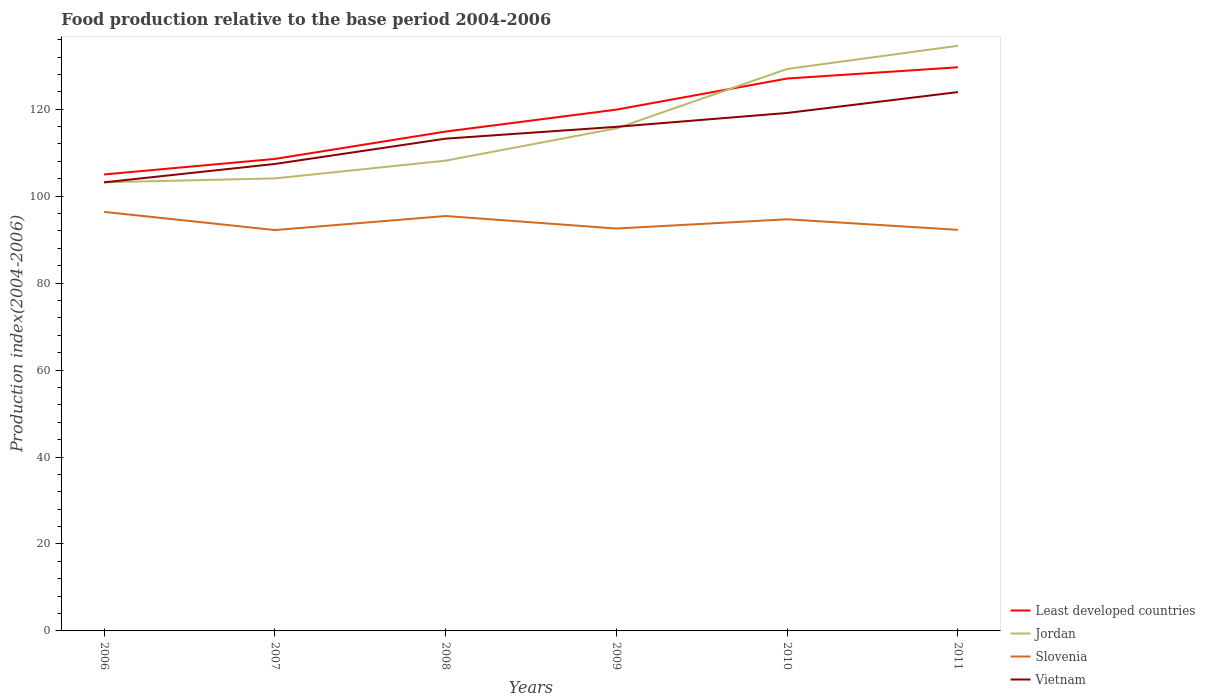How many different coloured lines are there?
Your answer should be compact. 4. Across all years, what is the maximum food production index in Slovenia?
Your response must be concise. 92.2. What is the total food production index in Least developed countries in the graph?
Give a very brief answer. -7.16. What is the difference between the highest and the second highest food production index in Vietnam?
Your answer should be very brief. 20.76. What is the difference between the highest and the lowest food production index in Slovenia?
Ensure brevity in your answer.  3. How many lines are there?
Provide a short and direct response. 4. Are the values on the major ticks of Y-axis written in scientific E-notation?
Provide a short and direct response. No. Does the graph contain any zero values?
Provide a short and direct response. No. Where does the legend appear in the graph?
Your answer should be compact. Bottom right. How many legend labels are there?
Offer a very short reply. 4. How are the legend labels stacked?
Give a very brief answer. Vertical. What is the title of the graph?
Keep it short and to the point. Food production relative to the base period 2004-2006. What is the label or title of the X-axis?
Keep it short and to the point. Years. What is the label or title of the Y-axis?
Ensure brevity in your answer.  Production index(2004-2006). What is the Production index(2004-2006) of Least developed countries in 2006?
Ensure brevity in your answer.  104.98. What is the Production index(2004-2006) in Jordan in 2006?
Offer a terse response. 103.18. What is the Production index(2004-2006) in Slovenia in 2006?
Provide a short and direct response. 96.38. What is the Production index(2004-2006) of Vietnam in 2006?
Offer a very short reply. 103.17. What is the Production index(2004-2006) of Least developed countries in 2007?
Your answer should be compact. 108.56. What is the Production index(2004-2006) in Jordan in 2007?
Offer a terse response. 104.08. What is the Production index(2004-2006) of Slovenia in 2007?
Make the answer very short. 92.2. What is the Production index(2004-2006) in Vietnam in 2007?
Make the answer very short. 107.4. What is the Production index(2004-2006) of Least developed countries in 2008?
Offer a very short reply. 114.85. What is the Production index(2004-2006) in Jordan in 2008?
Your answer should be very brief. 108.16. What is the Production index(2004-2006) of Slovenia in 2008?
Provide a short and direct response. 95.43. What is the Production index(2004-2006) in Vietnam in 2008?
Provide a succinct answer. 113.22. What is the Production index(2004-2006) in Least developed countries in 2009?
Provide a short and direct response. 119.89. What is the Production index(2004-2006) of Jordan in 2009?
Your response must be concise. 115.58. What is the Production index(2004-2006) in Slovenia in 2009?
Ensure brevity in your answer.  92.55. What is the Production index(2004-2006) in Vietnam in 2009?
Your response must be concise. 115.94. What is the Production index(2004-2006) in Least developed countries in 2010?
Your answer should be very brief. 127.05. What is the Production index(2004-2006) of Jordan in 2010?
Ensure brevity in your answer.  129.25. What is the Production index(2004-2006) in Slovenia in 2010?
Give a very brief answer. 94.68. What is the Production index(2004-2006) of Vietnam in 2010?
Offer a very short reply. 119.13. What is the Production index(2004-2006) in Least developed countries in 2011?
Provide a succinct answer. 129.63. What is the Production index(2004-2006) in Jordan in 2011?
Offer a terse response. 134.58. What is the Production index(2004-2006) in Slovenia in 2011?
Give a very brief answer. 92.25. What is the Production index(2004-2006) in Vietnam in 2011?
Provide a short and direct response. 123.93. Across all years, what is the maximum Production index(2004-2006) in Least developed countries?
Your answer should be compact. 129.63. Across all years, what is the maximum Production index(2004-2006) of Jordan?
Your answer should be very brief. 134.58. Across all years, what is the maximum Production index(2004-2006) of Slovenia?
Offer a very short reply. 96.38. Across all years, what is the maximum Production index(2004-2006) in Vietnam?
Offer a terse response. 123.93. Across all years, what is the minimum Production index(2004-2006) of Least developed countries?
Give a very brief answer. 104.98. Across all years, what is the minimum Production index(2004-2006) of Jordan?
Offer a very short reply. 103.18. Across all years, what is the minimum Production index(2004-2006) in Slovenia?
Provide a short and direct response. 92.2. Across all years, what is the minimum Production index(2004-2006) in Vietnam?
Provide a succinct answer. 103.17. What is the total Production index(2004-2006) of Least developed countries in the graph?
Provide a succinct answer. 704.97. What is the total Production index(2004-2006) of Jordan in the graph?
Ensure brevity in your answer.  694.83. What is the total Production index(2004-2006) in Slovenia in the graph?
Your response must be concise. 563.49. What is the total Production index(2004-2006) in Vietnam in the graph?
Your response must be concise. 682.79. What is the difference between the Production index(2004-2006) in Least developed countries in 2006 and that in 2007?
Ensure brevity in your answer.  -3.58. What is the difference between the Production index(2004-2006) of Jordan in 2006 and that in 2007?
Provide a succinct answer. -0.9. What is the difference between the Production index(2004-2006) in Slovenia in 2006 and that in 2007?
Your answer should be very brief. 4.18. What is the difference between the Production index(2004-2006) of Vietnam in 2006 and that in 2007?
Give a very brief answer. -4.23. What is the difference between the Production index(2004-2006) in Least developed countries in 2006 and that in 2008?
Your response must be concise. -9.87. What is the difference between the Production index(2004-2006) in Jordan in 2006 and that in 2008?
Provide a succinct answer. -4.98. What is the difference between the Production index(2004-2006) in Vietnam in 2006 and that in 2008?
Keep it short and to the point. -10.05. What is the difference between the Production index(2004-2006) of Least developed countries in 2006 and that in 2009?
Your answer should be compact. -14.91. What is the difference between the Production index(2004-2006) in Slovenia in 2006 and that in 2009?
Offer a very short reply. 3.83. What is the difference between the Production index(2004-2006) in Vietnam in 2006 and that in 2009?
Offer a terse response. -12.77. What is the difference between the Production index(2004-2006) of Least developed countries in 2006 and that in 2010?
Your response must be concise. -22.07. What is the difference between the Production index(2004-2006) in Jordan in 2006 and that in 2010?
Your answer should be compact. -26.07. What is the difference between the Production index(2004-2006) in Vietnam in 2006 and that in 2010?
Keep it short and to the point. -15.96. What is the difference between the Production index(2004-2006) in Least developed countries in 2006 and that in 2011?
Offer a terse response. -24.65. What is the difference between the Production index(2004-2006) of Jordan in 2006 and that in 2011?
Your answer should be compact. -31.4. What is the difference between the Production index(2004-2006) in Slovenia in 2006 and that in 2011?
Ensure brevity in your answer.  4.13. What is the difference between the Production index(2004-2006) of Vietnam in 2006 and that in 2011?
Provide a succinct answer. -20.76. What is the difference between the Production index(2004-2006) of Least developed countries in 2007 and that in 2008?
Give a very brief answer. -6.29. What is the difference between the Production index(2004-2006) of Jordan in 2007 and that in 2008?
Provide a short and direct response. -4.08. What is the difference between the Production index(2004-2006) in Slovenia in 2007 and that in 2008?
Your response must be concise. -3.23. What is the difference between the Production index(2004-2006) of Vietnam in 2007 and that in 2008?
Provide a short and direct response. -5.82. What is the difference between the Production index(2004-2006) in Least developed countries in 2007 and that in 2009?
Your answer should be compact. -11.33. What is the difference between the Production index(2004-2006) in Slovenia in 2007 and that in 2009?
Provide a short and direct response. -0.35. What is the difference between the Production index(2004-2006) of Vietnam in 2007 and that in 2009?
Provide a short and direct response. -8.54. What is the difference between the Production index(2004-2006) of Least developed countries in 2007 and that in 2010?
Offer a terse response. -18.49. What is the difference between the Production index(2004-2006) in Jordan in 2007 and that in 2010?
Keep it short and to the point. -25.17. What is the difference between the Production index(2004-2006) in Slovenia in 2007 and that in 2010?
Make the answer very short. -2.48. What is the difference between the Production index(2004-2006) of Vietnam in 2007 and that in 2010?
Provide a short and direct response. -11.73. What is the difference between the Production index(2004-2006) in Least developed countries in 2007 and that in 2011?
Ensure brevity in your answer.  -21.07. What is the difference between the Production index(2004-2006) in Jordan in 2007 and that in 2011?
Your answer should be compact. -30.5. What is the difference between the Production index(2004-2006) of Slovenia in 2007 and that in 2011?
Ensure brevity in your answer.  -0.05. What is the difference between the Production index(2004-2006) of Vietnam in 2007 and that in 2011?
Offer a terse response. -16.53. What is the difference between the Production index(2004-2006) of Least developed countries in 2008 and that in 2009?
Offer a terse response. -5.04. What is the difference between the Production index(2004-2006) of Jordan in 2008 and that in 2009?
Make the answer very short. -7.42. What is the difference between the Production index(2004-2006) of Slovenia in 2008 and that in 2009?
Give a very brief answer. 2.88. What is the difference between the Production index(2004-2006) of Vietnam in 2008 and that in 2009?
Ensure brevity in your answer.  -2.72. What is the difference between the Production index(2004-2006) of Least developed countries in 2008 and that in 2010?
Ensure brevity in your answer.  -12.2. What is the difference between the Production index(2004-2006) of Jordan in 2008 and that in 2010?
Give a very brief answer. -21.09. What is the difference between the Production index(2004-2006) in Slovenia in 2008 and that in 2010?
Keep it short and to the point. 0.75. What is the difference between the Production index(2004-2006) of Vietnam in 2008 and that in 2010?
Your answer should be very brief. -5.91. What is the difference between the Production index(2004-2006) of Least developed countries in 2008 and that in 2011?
Provide a short and direct response. -14.78. What is the difference between the Production index(2004-2006) of Jordan in 2008 and that in 2011?
Your response must be concise. -26.42. What is the difference between the Production index(2004-2006) in Slovenia in 2008 and that in 2011?
Offer a terse response. 3.18. What is the difference between the Production index(2004-2006) of Vietnam in 2008 and that in 2011?
Provide a short and direct response. -10.71. What is the difference between the Production index(2004-2006) in Least developed countries in 2009 and that in 2010?
Make the answer very short. -7.16. What is the difference between the Production index(2004-2006) in Jordan in 2009 and that in 2010?
Give a very brief answer. -13.67. What is the difference between the Production index(2004-2006) of Slovenia in 2009 and that in 2010?
Make the answer very short. -2.13. What is the difference between the Production index(2004-2006) in Vietnam in 2009 and that in 2010?
Your response must be concise. -3.19. What is the difference between the Production index(2004-2006) in Least developed countries in 2009 and that in 2011?
Your answer should be very brief. -9.74. What is the difference between the Production index(2004-2006) in Jordan in 2009 and that in 2011?
Ensure brevity in your answer.  -19. What is the difference between the Production index(2004-2006) in Slovenia in 2009 and that in 2011?
Provide a short and direct response. 0.3. What is the difference between the Production index(2004-2006) of Vietnam in 2009 and that in 2011?
Your answer should be very brief. -7.99. What is the difference between the Production index(2004-2006) in Least developed countries in 2010 and that in 2011?
Provide a succinct answer. -2.58. What is the difference between the Production index(2004-2006) of Jordan in 2010 and that in 2011?
Make the answer very short. -5.33. What is the difference between the Production index(2004-2006) in Slovenia in 2010 and that in 2011?
Your answer should be compact. 2.43. What is the difference between the Production index(2004-2006) in Vietnam in 2010 and that in 2011?
Offer a terse response. -4.8. What is the difference between the Production index(2004-2006) in Least developed countries in 2006 and the Production index(2004-2006) in Jordan in 2007?
Ensure brevity in your answer.  0.9. What is the difference between the Production index(2004-2006) in Least developed countries in 2006 and the Production index(2004-2006) in Slovenia in 2007?
Make the answer very short. 12.78. What is the difference between the Production index(2004-2006) in Least developed countries in 2006 and the Production index(2004-2006) in Vietnam in 2007?
Make the answer very short. -2.42. What is the difference between the Production index(2004-2006) in Jordan in 2006 and the Production index(2004-2006) in Slovenia in 2007?
Your answer should be compact. 10.98. What is the difference between the Production index(2004-2006) of Jordan in 2006 and the Production index(2004-2006) of Vietnam in 2007?
Your response must be concise. -4.22. What is the difference between the Production index(2004-2006) of Slovenia in 2006 and the Production index(2004-2006) of Vietnam in 2007?
Your answer should be compact. -11.02. What is the difference between the Production index(2004-2006) of Least developed countries in 2006 and the Production index(2004-2006) of Jordan in 2008?
Offer a very short reply. -3.18. What is the difference between the Production index(2004-2006) in Least developed countries in 2006 and the Production index(2004-2006) in Slovenia in 2008?
Ensure brevity in your answer.  9.55. What is the difference between the Production index(2004-2006) of Least developed countries in 2006 and the Production index(2004-2006) of Vietnam in 2008?
Ensure brevity in your answer.  -8.24. What is the difference between the Production index(2004-2006) of Jordan in 2006 and the Production index(2004-2006) of Slovenia in 2008?
Provide a short and direct response. 7.75. What is the difference between the Production index(2004-2006) of Jordan in 2006 and the Production index(2004-2006) of Vietnam in 2008?
Provide a short and direct response. -10.04. What is the difference between the Production index(2004-2006) in Slovenia in 2006 and the Production index(2004-2006) in Vietnam in 2008?
Make the answer very short. -16.84. What is the difference between the Production index(2004-2006) in Least developed countries in 2006 and the Production index(2004-2006) in Jordan in 2009?
Your answer should be compact. -10.6. What is the difference between the Production index(2004-2006) of Least developed countries in 2006 and the Production index(2004-2006) of Slovenia in 2009?
Provide a short and direct response. 12.43. What is the difference between the Production index(2004-2006) in Least developed countries in 2006 and the Production index(2004-2006) in Vietnam in 2009?
Provide a succinct answer. -10.96. What is the difference between the Production index(2004-2006) of Jordan in 2006 and the Production index(2004-2006) of Slovenia in 2009?
Provide a short and direct response. 10.63. What is the difference between the Production index(2004-2006) in Jordan in 2006 and the Production index(2004-2006) in Vietnam in 2009?
Give a very brief answer. -12.76. What is the difference between the Production index(2004-2006) of Slovenia in 2006 and the Production index(2004-2006) of Vietnam in 2009?
Offer a terse response. -19.56. What is the difference between the Production index(2004-2006) of Least developed countries in 2006 and the Production index(2004-2006) of Jordan in 2010?
Ensure brevity in your answer.  -24.27. What is the difference between the Production index(2004-2006) in Least developed countries in 2006 and the Production index(2004-2006) in Slovenia in 2010?
Ensure brevity in your answer.  10.3. What is the difference between the Production index(2004-2006) in Least developed countries in 2006 and the Production index(2004-2006) in Vietnam in 2010?
Offer a very short reply. -14.15. What is the difference between the Production index(2004-2006) in Jordan in 2006 and the Production index(2004-2006) in Slovenia in 2010?
Give a very brief answer. 8.5. What is the difference between the Production index(2004-2006) in Jordan in 2006 and the Production index(2004-2006) in Vietnam in 2010?
Provide a succinct answer. -15.95. What is the difference between the Production index(2004-2006) in Slovenia in 2006 and the Production index(2004-2006) in Vietnam in 2010?
Ensure brevity in your answer.  -22.75. What is the difference between the Production index(2004-2006) of Least developed countries in 2006 and the Production index(2004-2006) of Jordan in 2011?
Give a very brief answer. -29.6. What is the difference between the Production index(2004-2006) in Least developed countries in 2006 and the Production index(2004-2006) in Slovenia in 2011?
Your answer should be compact. 12.73. What is the difference between the Production index(2004-2006) of Least developed countries in 2006 and the Production index(2004-2006) of Vietnam in 2011?
Your response must be concise. -18.95. What is the difference between the Production index(2004-2006) in Jordan in 2006 and the Production index(2004-2006) in Slovenia in 2011?
Your response must be concise. 10.93. What is the difference between the Production index(2004-2006) of Jordan in 2006 and the Production index(2004-2006) of Vietnam in 2011?
Make the answer very short. -20.75. What is the difference between the Production index(2004-2006) in Slovenia in 2006 and the Production index(2004-2006) in Vietnam in 2011?
Provide a succinct answer. -27.55. What is the difference between the Production index(2004-2006) of Least developed countries in 2007 and the Production index(2004-2006) of Jordan in 2008?
Offer a very short reply. 0.4. What is the difference between the Production index(2004-2006) of Least developed countries in 2007 and the Production index(2004-2006) of Slovenia in 2008?
Your answer should be very brief. 13.13. What is the difference between the Production index(2004-2006) of Least developed countries in 2007 and the Production index(2004-2006) of Vietnam in 2008?
Give a very brief answer. -4.66. What is the difference between the Production index(2004-2006) of Jordan in 2007 and the Production index(2004-2006) of Slovenia in 2008?
Your response must be concise. 8.65. What is the difference between the Production index(2004-2006) in Jordan in 2007 and the Production index(2004-2006) in Vietnam in 2008?
Your response must be concise. -9.14. What is the difference between the Production index(2004-2006) in Slovenia in 2007 and the Production index(2004-2006) in Vietnam in 2008?
Your answer should be very brief. -21.02. What is the difference between the Production index(2004-2006) in Least developed countries in 2007 and the Production index(2004-2006) in Jordan in 2009?
Keep it short and to the point. -7.02. What is the difference between the Production index(2004-2006) in Least developed countries in 2007 and the Production index(2004-2006) in Slovenia in 2009?
Your response must be concise. 16.01. What is the difference between the Production index(2004-2006) of Least developed countries in 2007 and the Production index(2004-2006) of Vietnam in 2009?
Provide a short and direct response. -7.38. What is the difference between the Production index(2004-2006) in Jordan in 2007 and the Production index(2004-2006) in Slovenia in 2009?
Your answer should be very brief. 11.53. What is the difference between the Production index(2004-2006) of Jordan in 2007 and the Production index(2004-2006) of Vietnam in 2009?
Provide a short and direct response. -11.86. What is the difference between the Production index(2004-2006) in Slovenia in 2007 and the Production index(2004-2006) in Vietnam in 2009?
Give a very brief answer. -23.74. What is the difference between the Production index(2004-2006) in Least developed countries in 2007 and the Production index(2004-2006) in Jordan in 2010?
Give a very brief answer. -20.69. What is the difference between the Production index(2004-2006) in Least developed countries in 2007 and the Production index(2004-2006) in Slovenia in 2010?
Make the answer very short. 13.88. What is the difference between the Production index(2004-2006) in Least developed countries in 2007 and the Production index(2004-2006) in Vietnam in 2010?
Give a very brief answer. -10.57. What is the difference between the Production index(2004-2006) in Jordan in 2007 and the Production index(2004-2006) in Slovenia in 2010?
Give a very brief answer. 9.4. What is the difference between the Production index(2004-2006) in Jordan in 2007 and the Production index(2004-2006) in Vietnam in 2010?
Your answer should be very brief. -15.05. What is the difference between the Production index(2004-2006) of Slovenia in 2007 and the Production index(2004-2006) of Vietnam in 2010?
Your answer should be very brief. -26.93. What is the difference between the Production index(2004-2006) of Least developed countries in 2007 and the Production index(2004-2006) of Jordan in 2011?
Offer a terse response. -26.02. What is the difference between the Production index(2004-2006) of Least developed countries in 2007 and the Production index(2004-2006) of Slovenia in 2011?
Offer a terse response. 16.31. What is the difference between the Production index(2004-2006) of Least developed countries in 2007 and the Production index(2004-2006) of Vietnam in 2011?
Keep it short and to the point. -15.37. What is the difference between the Production index(2004-2006) in Jordan in 2007 and the Production index(2004-2006) in Slovenia in 2011?
Provide a succinct answer. 11.83. What is the difference between the Production index(2004-2006) in Jordan in 2007 and the Production index(2004-2006) in Vietnam in 2011?
Your answer should be compact. -19.85. What is the difference between the Production index(2004-2006) of Slovenia in 2007 and the Production index(2004-2006) of Vietnam in 2011?
Provide a succinct answer. -31.73. What is the difference between the Production index(2004-2006) of Least developed countries in 2008 and the Production index(2004-2006) of Jordan in 2009?
Your answer should be compact. -0.73. What is the difference between the Production index(2004-2006) of Least developed countries in 2008 and the Production index(2004-2006) of Slovenia in 2009?
Keep it short and to the point. 22.3. What is the difference between the Production index(2004-2006) of Least developed countries in 2008 and the Production index(2004-2006) of Vietnam in 2009?
Provide a short and direct response. -1.09. What is the difference between the Production index(2004-2006) of Jordan in 2008 and the Production index(2004-2006) of Slovenia in 2009?
Ensure brevity in your answer.  15.61. What is the difference between the Production index(2004-2006) in Jordan in 2008 and the Production index(2004-2006) in Vietnam in 2009?
Your answer should be very brief. -7.78. What is the difference between the Production index(2004-2006) in Slovenia in 2008 and the Production index(2004-2006) in Vietnam in 2009?
Your response must be concise. -20.51. What is the difference between the Production index(2004-2006) in Least developed countries in 2008 and the Production index(2004-2006) in Jordan in 2010?
Offer a very short reply. -14.4. What is the difference between the Production index(2004-2006) of Least developed countries in 2008 and the Production index(2004-2006) of Slovenia in 2010?
Your answer should be very brief. 20.17. What is the difference between the Production index(2004-2006) of Least developed countries in 2008 and the Production index(2004-2006) of Vietnam in 2010?
Provide a short and direct response. -4.28. What is the difference between the Production index(2004-2006) of Jordan in 2008 and the Production index(2004-2006) of Slovenia in 2010?
Give a very brief answer. 13.48. What is the difference between the Production index(2004-2006) of Jordan in 2008 and the Production index(2004-2006) of Vietnam in 2010?
Provide a succinct answer. -10.97. What is the difference between the Production index(2004-2006) in Slovenia in 2008 and the Production index(2004-2006) in Vietnam in 2010?
Make the answer very short. -23.7. What is the difference between the Production index(2004-2006) of Least developed countries in 2008 and the Production index(2004-2006) of Jordan in 2011?
Your answer should be very brief. -19.73. What is the difference between the Production index(2004-2006) in Least developed countries in 2008 and the Production index(2004-2006) in Slovenia in 2011?
Your response must be concise. 22.6. What is the difference between the Production index(2004-2006) of Least developed countries in 2008 and the Production index(2004-2006) of Vietnam in 2011?
Offer a terse response. -9.08. What is the difference between the Production index(2004-2006) in Jordan in 2008 and the Production index(2004-2006) in Slovenia in 2011?
Offer a very short reply. 15.91. What is the difference between the Production index(2004-2006) of Jordan in 2008 and the Production index(2004-2006) of Vietnam in 2011?
Give a very brief answer. -15.77. What is the difference between the Production index(2004-2006) of Slovenia in 2008 and the Production index(2004-2006) of Vietnam in 2011?
Make the answer very short. -28.5. What is the difference between the Production index(2004-2006) in Least developed countries in 2009 and the Production index(2004-2006) in Jordan in 2010?
Give a very brief answer. -9.36. What is the difference between the Production index(2004-2006) of Least developed countries in 2009 and the Production index(2004-2006) of Slovenia in 2010?
Your answer should be very brief. 25.21. What is the difference between the Production index(2004-2006) of Least developed countries in 2009 and the Production index(2004-2006) of Vietnam in 2010?
Offer a terse response. 0.76. What is the difference between the Production index(2004-2006) in Jordan in 2009 and the Production index(2004-2006) in Slovenia in 2010?
Provide a succinct answer. 20.9. What is the difference between the Production index(2004-2006) of Jordan in 2009 and the Production index(2004-2006) of Vietnam in 2010?
Your response must be concise. -3.55. What is the difference between the Production index(2004-2006) of Slovenia in 2009 and the Production index(2004-2006) of Vietnam in 2010?
Offer a terse response. -26.58. What is the difference between the Production index(2004-2006) of Least developed countries in 2009 and the Production index(2004-2006) of Jordan in 2011?
Keep it short and to the point. -14.69. What is the difference between the Production index(2004-2006) in Least developed countries in 2009 and the Production index(2004-2006) in Slovenia in 2011?
Offer a very short reply. 27.64. What is the difference between the Production index(2004-2006) in Least developed countries in 2009 and the Production index(2004-2006) in Vietnam in 2011?
Keep it short and to the point. -4.04. What is the difference between the Production index(2004-2006) of Jordan in 2009 and the Production index(2004-2006) of Slovenia in 2011?
Your answer should be very brief. 23.33. What is the difference between the Production index(2004-2006) of Jordan in 2009 and the Production index(2004-2006) of Vietnam in 2011?
Keep it short and to the point. -8.35. What is the difference between the Production index(2004-2006) of Slovenia in 2009 and the Production index(2004-2006) of Vietnam in 2011?
Your answer should be compact. -31.38. What is the difference between the Production index(2004-2006) in Least developed countries in 2010 and the Production index(2004-2006) in Jordan in 2011?
Your answer should be very brief. -7.53. What is the difference between the Production index(2004-2006) in Least developed countries in 2010 and the Production index(2004-2006) in Slovenia in 2011?
Your answer should be very brief. 34.8. What is the difference between the Production index(2004-2006) in Least developed countries in 2010 and the Production index(2004-2006) in Vietnam in 2011?
Your answer should be compact. 3.12. What is the difference between the Production index(2004-2006) of Jordan in 2010 and the Production index(2004-2006) of Vietnam in 2011?
Your response must be concise. 5.32. What is the difference between the Production index(2004-2006) of Slovenia in 2010 and the Production index(2004-2006) of Vietnam in 2011?
Your answer should be compact. -29.25. What is the average Production index(2004-2006) in Least developed countries per year?
Provide a succinct answer. 117.5. What is the average Production index(2004-2006) in Jordan per year?
Your answer should be very brief. 115.81. What is the average Production index(2004-2006) in Slovenia per year?
Your answer should be very brief. 93.92. What is the average Production index(2004-2006) in Vietnam per year?
Your response must be concise. 113.8. In the year 2006, what is the difference between the Production index(2004-2006) in Least developed countries and Production index(2004-2006) in Jordan?
Offer a terse response. 1.8. In the year 2006, what is the difference between the Production index(2004-2006) of Least developed countries and Production index(2004-2006) of Slovenia?
Keep it short and to the point. 8.6. In the year 2006, what is the difference between the Production index(2004-2006) of Least developed countries and Production index(2004-2006) of Vietnam?
Provide a short and direct response. 1.81. In the year 2006, what is the difference between the Production index(2004-2006) in Jordan and Production index(2004-2006) in Slovenia?
Your answer should be compact. 6.8. In the year 2006, what is the difference between the Production index(2004-2006) in Slovenia and Production index(2004-2006) in Vietnam?
Provide a succinct answer. -6.79. In the year 2007, what is the difference between the Production index(2004-2006) in Least developed countries and Production index(2004-2006) in Jordan?
Offer a terse response. 4.48. In the year 2007, what is the difference between the Production index(2004-2006) of Least developed countries and Production index(2004-2006) of Slovenia?
Offer a very short reply. 16.36. In the year 2007, what is the difference between the Production index(2004-2006) of Least developed countries and Production index(2004-2006) of Vietnam?
Provide a succinct answer. 1.16. In the year 2007, what is the difference between the Production index(2004-2006) in Jordan and Production index(2004-2006) in Slovenia?
Your response must be concise. 11.88. In the year 2007, what is the difference between the Production index(2004-2006) in Jordan and Production index(2004-2006) in Vietnam?
Offer a very short reply. -3.32. In the year 2007, what is the difference between the Production index(2004-2006) of Slovenia and Production index(2004-2006) of Vietnam?
Your answer should be very brief. -15.2. In the year 2008, what is the difference between the Production index(2004-2006) in Least developed countries and Production index(2004-2006) in Jordan?
Your answer should be very brief. 6.69. In the year 2008, what is the difference between the Production index(2004-2006) in Least developed countries and Production index(2004-2006) in Slovenia?
Your answer should be compact. 19.42. In the year 2008, what is the difference between the Production index(2004-2006) of Least developed countries and Production index(2004-2006) of Vietnam?
Make the answer very short. 1.63. In the year 2008, what is the difference between the Production index(2004-2006) in Jordan and Production index(2004-2006) in Slovenia?
Your response must be concise. 12.73. In the year 2008, what is the difference between the Production index(2004-2006) of Jordan and Production index(2004-2006) of Vietnam?
Give a very brief answer. -5.06. In the year 2008, what is the difference between the Production index(2004-2006) in Slovenia and Production index(2004-2006) in Vietnam?
Provide a succinct answer. -17.79. In the year 2009, what is the difference between the Production index(2004-2006) of Least developed countries and Production index(2004-2006) of Jordan?
Provide a short and direct response. 4.31. In the year 2009, what is the difference between the Production index(2004-2006) in Least developed countries and Production index(2004-2006) in Slovenia?
Provide a succinct answer. 27.34. In the year 2009, what is the difference between the Production index(2004-2006) of Least developed countries and Production index(2004-2006) of Vietnam?
Offer a terse response. 3.95. In the year 2009, what is the difference between the Production index(2004-2006) in Jordan and Production index(2004-2006) in Slovenia?
Provide a short and direct response. 23.03. In the year 2009, what is the difference between the Production index(2004-2006) of Jordan and Production index(2004-2006) of Vietnam?
Provide a short and direct response. -0.36. In the year 2009, what is the difference between the Production index(2004-2006) in Slovenia and Production index(2004-2006) in Vietnam?
Your answer should be very brief. -23.39. In the year 2010, what is the difference between the Production index(2004-2006) in Least developed countries and Production index(2004-2006) in Jordan?
Provide a succinct answer. -2.2. In the year 2010, what is the difference between the Production index(2004-2006) of Least developed countries and Production index(2004-2006) of Slovenia?
Keep it short and to the point. 32.37. In the year 2010, what is the difference between the Production index(2004-2006) of Least developed countries and Production index(2004-2006) of Vietnam?
Provide a short and direct response. 7.92. In the year 2010, what is the difference between the Production index(2004-2006) of Jordan and Production index(2004-2006) of Slovenia?
Give a very brief answer. 34.57. In the year 2010, what is the difference between the Production index(2004-2006) in Jordan and Production index(2004-2006) in Vietnam?
Ensure brevity in your answer.  10.12. In the year 2010, what is the difference between the Production index(2004-2006) of Slovenia and Production index(2004-2006) of Vietnam?
Offer a terse response. -24.45. In the year 2011, what is the difference between the Production index(2004-2006) of Least developed countries and Production index(2004-2006) of Jordan?
Your answer should be compact. -4.95. In the year 2011, what is the difference between the Production index(2004-2006) of Least developed countries and Production index(2004-2006) of Slovenia?
Ensure brevity in your answer.  37.38. In the year 2011, what is the difference between the Production index(2004-2006) in Least developed countries and Production index(2004-2006) in Vietnam?
Your answer should be compact. 5.7. In the year 2011, what is the difference between the Production index(2004-2006) in Jordan and Production index(2004-2006) in Slovenia?
Your answer should be very brief. 42.33. In the year 2011, what is the difference between the Production index(2004-2006) of Jordan and Production index(2004-2006) of Vietnam?
Provide a short and direct response. 10.65. In the year 2011, what is the difference between the Production index(2004-2006) in Slovenia and Production index(2004-2006) in Vietnam?
Your answer should be very brief. -31.68. What is the ratio of the Production index(2004-2006) in Jordan in 2006 to that in 2007?
Keep it short and to the point. 0.99. What is the ratio of the Production index(2004-2006) in Slovenia in 2006 to that in 2007?
Your response must be concise. 1.05. What is the ratio of the Production index(2004-2006) in Vietnam in 2006 to that in 2007?
Your answer should be very brief. 0.96. What is the ratio of the Production index(2004-2006) of Least developed countries in 2006 to that in 2008?
Keep it short and to the point. 0.91. What is the ratio of the Production index(2004-2006) of Jordan in 2006 to that in 2008?
Your answer should be very brief. 0.95. What is the ratio of the Production index(2004-2006) in Slovenia in 2006 to that in 2008?
Offer a terse response. 1.01. What is the ratio of the Production index(2004-2006) in Vietnam in 2006 to that in 2008?
Your answer should be compact. 0.91. What is the ratio of the Production index(2004-2006) of Least developed countries in 2006 to that in 2009?
Keep it short and to the point. 0.88. What is the ratio of the Production index(2004-2006) of Jordan in 2006 to that in 2009?
Your answer should be very brief. 0.89. What is the ratio of the Production index(2004-2006) of Slovenia in 2006 to that in 2009?
Ensure brevity in your answer.  1.04. What is the ratio of the Production index(2004-2006) of Vietnam in 2006 to that in 2009?
Your answer should be compact. 0.89. What is the ratio of the Production index(2004-2006) of Least developed countries in 2006 to that in 2010?
Provide a succinct answer. 0.83. What is the ratio of the Production index(2004-2006) in Jordan in 2006 to that in 2010?
Ensure brevity in your answer.  0.8. What is the ratio of the Production index(2004-2006) in Vietnam in 2006 to that in 2010?
Keep it short and to the point. 0.87. What is the ratio of the Production index(2004-2006) of Least developed countries in 2006 to that in 2011?
Ensure brevity in your answer.  0.81. What is the ratio of the Production index(2004-2006) in Jordan in 2006 to that in 2011?
Your answer should be very brief. 0.77. What is the ratio of the Production index(2004-2006) of Slovenia in 2006 to that in 2011?
Provide a short and direct response. 1.04. What is the ratio of the Production index(2004-2006) in Vietnam in 2006 to that in 2011?
Give a very brief answer. 0.83. What is the ratio of the Production index(2004-2006) in Least developed countries in 2007 to that in 2008?
Offer a terse response. 0.95. What is the ratio of the Production index(2004-2006) in Jordan in 2007 to that in 2008?
Make the answer very short. 0.96. What is the ratio of the Production index(2004-2006) of Slovenia in 2007 to that in 2008?
Provide a succinct answer. 0.97. What is the ratio of the Production index(2004-2006) in Vietnam in 2007 to that in 2008?
Your answer should be compact. 0.95. What is the ratio of the Production index(2004-2006) of Least developed countries in 2007 to that in 2009?
Your answer should be very brief. 0.91. What is the ratio of the Production index(2004-2006) of Jordan in 2007 to that in 2009?
Your answer should be compact. 0.9. What is the ratio of the Production index(2004-2006) of Vietnam in 2007 to that in 2009?
Give a very brief answer. 0.93. What is the ratio of the Production index(2004-2006) of Least developed countries in 2007 to that in 2010?
Provide a short and direct response. 0.85. What is the ratio of the Production index(2004-2006) of Jordan in 2007 to that in 2010?
Your answer should be compact. 0.81. What is the ratio of the Production index(2004-2006) in Slovenia in 2007 to that in 2010?
Offer a terse response. 0.97. What is the ratio of the Production index(2004-2006) of Vietnam in 2007 to that in 2010?
Provide a succinct answer. 0.9. What is the ratio of the Production index(2004-2006) in Least developed countries in 2007 to that in 2011?
Keep it short and to the point. 0.84. What is the ratio of the Production index(2004-2006) of Jordan in 2007 to that in 2011?
Give a very brief answer. 0.77. What is the ratio of the Production index(2004-2006) in Vietnam in 2007 to that in 2011?
Your response must be concise. 0.87. What is the ratio of the Production index(2004-2006) of Least developed countries in 2008 to that in 2009?
Ensure brevity in your answer.  0.96. What is the ratio of the Production index(2004-2006) of Jordan in 2008 to that in 2009?
Make the answer very short. 0.94. What is the ratio of the Production index(2004-2006) of Slovenia in 2008 to that in 2009?
Offer a very short reply. 1.03. What is the ratio of the Production index(2004-2006) of Vietnam in 2008 to that in 2009?
Keep it short and to the point. 0.98. What is the ratio of the Production index(2004-2006) of Least developed countries in 2008 to that in 2010?
Offer a terse response. 0.9. What is the ratio of the Production index(2004-2006) in Jordan in 2008 to that in 2010?
Provide a short and direct response. 0.84. What is the ratio of the Production index(2004-2006) of Slovenia in 2008 to that in 2010?
Keep it short and to the point. 1.01. What is the ratio of the Production index(2004-2006) of Vietnam in 2008 to that in 2010?
Your response must be concise. 0.95. What is the ratio of the Production index(2004-2006) of Least developed countries in 2008 to that in 2011?
Your answer should be very brief. 0.89. What is the ratio of the Production index(2004-2006) of Jordan in 2008 to that in 2011?
Your response must be concise. 0.8. What is the ratio of the Production index(2004-2006) of Slovenia in 2008 to that in 2011?
Your answer should be compact. 1.03. What is the ratio of the Production index(2004-2006) of Vietnam in 2008 to that in 2011?
Offer a very short reply. 0.91. What is the ratio of the Production index(2004-2006) of Least developed countries in 2009 to that in 2010?
Provide a succinct answer. 0.94. What is the ratio of the Production index(2004-2006) of Jordan in 2009 to that in 2010?
Offer a very short reply. 0.89. What is the ratio of the Production index(2004-2006) of Slovenia in 2009 to that in 2010?
Keep it short and to the point. 0.98. What is the ratio of the Production index(2004-2006) of Vietnam in 2009 to that in 2010?
Keep it short and to the point. 0.97. What is the ratio of the Production index(2004-2006) of Least developed countries in 2009 to that in 2011?
Make the answer very short. 0.92. What is the ratio of the Production index(2004-2006) of Jordan in 2009 to that in 2011?
Your response must be concise. 0.86. What is the ratio of the Production index(2004-2006) in Slovenia in 2009 to that in 2011?
Give a very brief answer. 1. What is the ratio of the Production index(2004-2006) of Vietnam in 2009 to that in 2011?
Keep it short and to the point. 0.94. What is the ratio of the Production index(2004-2006) in Least developed countries in 2010 to that in 2011?
Make the answer very short. 0.98. What is the ratio of the Production index(2004-2006) in Jordan in 2010 to that in 2011?
Make the answer very short. 0.96. What is the ratio of the Production index(2004-2006) of Slovenia in 2010 to that in 2011?
Offer a terse response. 1.03. What is the ratio of the Production index(2004-2006) of Vietnam in 2010 to that in 2011?
Offer a terse response. 0.96. What is the difference between the highest and the second highest Production index(2004-2006) of Least developed countries?
Your answer should be very brief. 2.58. What is the difference between the highest and the second highest Production index(2004-2006) of Jordan?
Your answer should be very brief. 5.33. What is the difference between the highest and the second highest Production index(2004-2006) of Slovenia?
Give a very brief answer. 0.95. What is the difference between the highest and the second highest Production index(2004-2006) of Vietnam?
Keep it short and to the point. 4.8. What is the difference between the highest and the lowest Production index(2004-2006) of Least developed countries?
Provide a short and direct response. 24.65. What is the difference between the highest and the lowest Production index(2004-2006) in Jordan?
Keep it short and to the point. 31.4. What is the difference between the highest and the lowest Production index(2004-2006) in Slovenia?
Give a very brief answer. 4.18. What is the difference between the highest and the lowest Production index(2004-2006) of Vietnam?
Offer a very short reply. 20.76. 